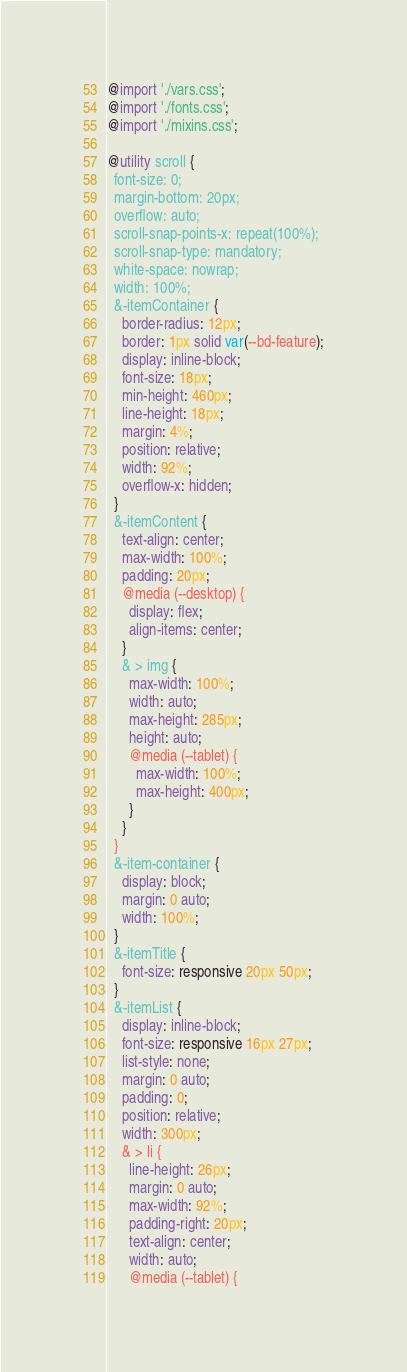<code> <loc_0><loc_0><loc_500><loc_500><_CSS_>@import './vars.css';
@import './fonts.css';
@import './mixins.css';

@utility scroll {
  font-size: 0;
  margin-bottom: 20px;
  overflow: auto;
  scroll-snap-points-x: repeat(100%);
  scroll-snap-type: mandatory;
  white-space: nowrap;
  width: 100%;
  &-itemContainer {
    border-radius: 12px;
    border: 1px solid var(--bd-feature);
    display: inline-block;
    font-size: 18px;
    min-height: 460px;
    line-height: 18px;
    margin: 4%;
    position: relative;
    width: 92%;
    overflow-x: hidden;
  }
  &-itemContent {
    text-align: center;
    max-width: 100%;
    padding: 20px;
    @media (--desktop) {
      display: flex;
      align-items: center;
    }
    & > img {
      max-width: 100%;
      width: auto;
      max-height: 285px;
      height: auto;
      @media (--tablet) {
        max-width: 100%;
        max-height: 400px;
      }
    }
  }
  &-item-container {
    display: block;
    margin: 0 auto;
    width: 100%;
  }
  &-itemTitle {
    font-size: responsive 20px 50px;
  }
  &-itemList {
    display: inline-block;
    font-size: responsive 16px 27px;
    list-style: none;
    margin: 0 auto;
    padding: 0;
    position: relative;
    width: 300px;
    & > li {
      line-height: 26px;
      margin: 0 auto;
      max-width: 92%;
      padding-right: 20px;
      text-align: center;
      width: auto;
      @media (--tablet) {</code> 